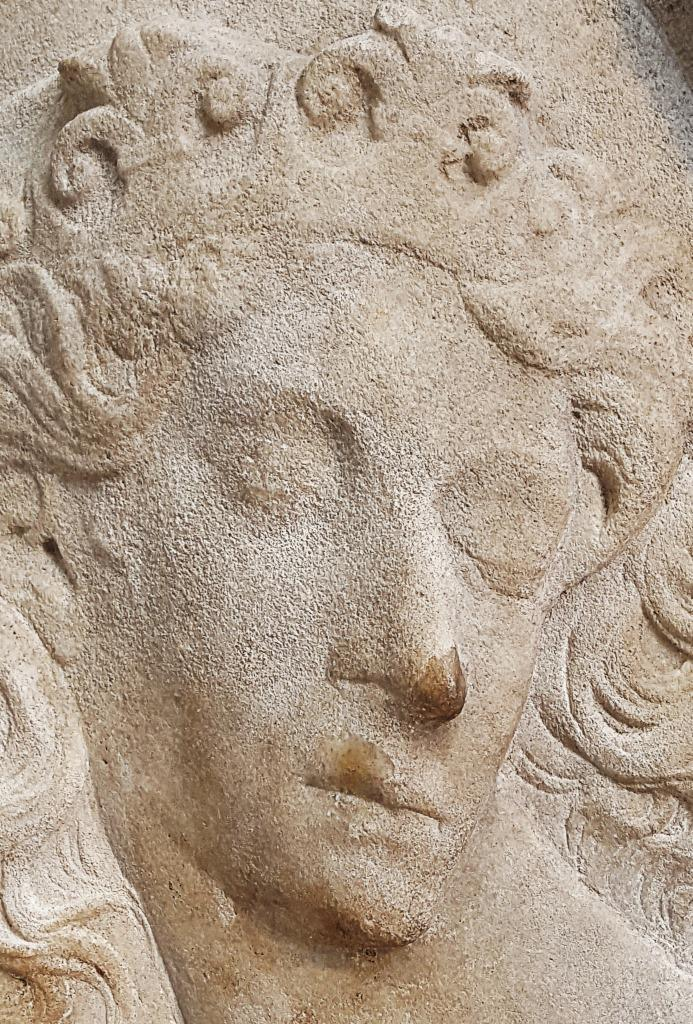What is the main subject of the image? There is a sculpture of a person in the image. Can you describe the sculpture in more detail? Unfortunately, the provided facts do not give any additional details about the sculpture. What might the sculpture be made of? The material used to create the sculpture is not mentioned in the given facts. What type of arch can be seen supporting the rake in the image? There is no arch or rake present in the image; it only features a sculpture of a person. 